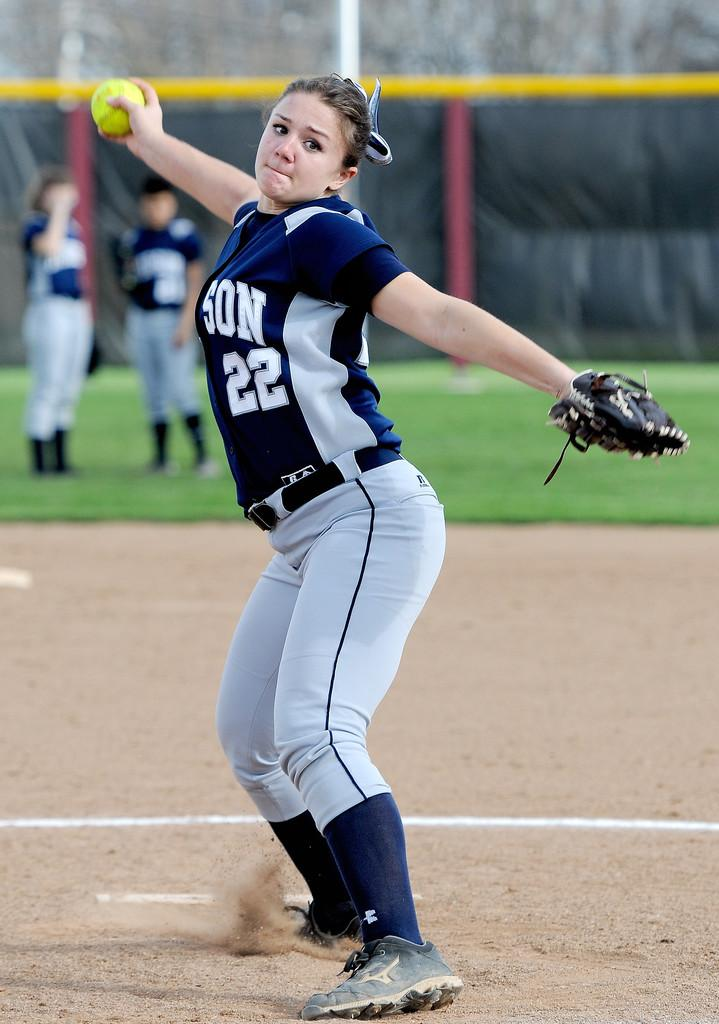<image>
Relay a brief, clear account of the picture shown. The woman pitching the softball is number 22. 